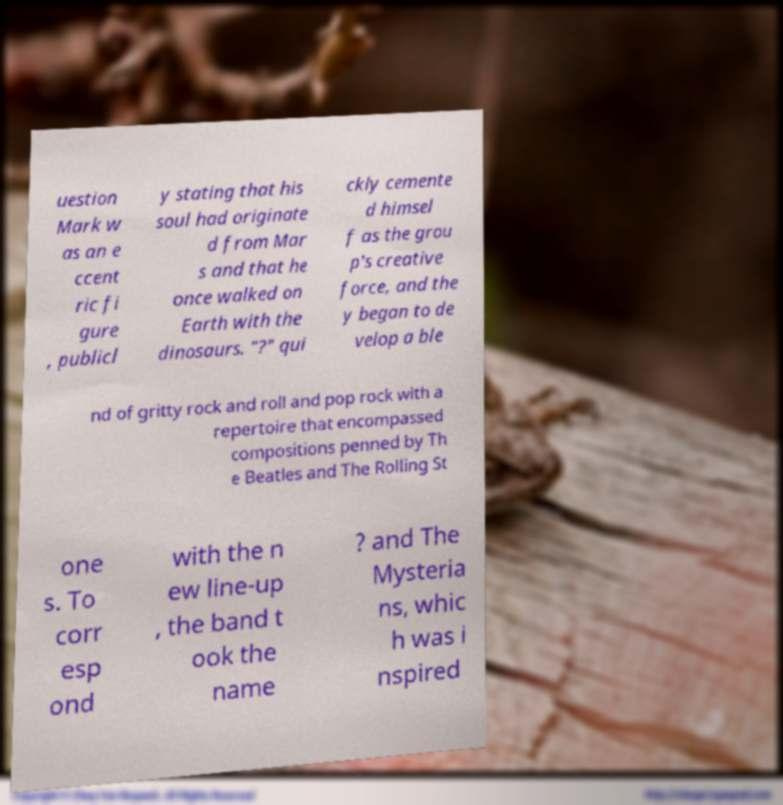Can you read and provide the text displayed in the image?This photo seems to have some interesting text. Can you extract and type it out for me? uestion Mark w as an e ccent ric fi gure , publicl y stating that his soul had originate d from Mar s and that he once walked on Earth with the dinosaurs. "?" qui ckly cemente d himsel f as the grou p's creative force, and the y began to de velop a ble nd of gritty rock and roll and pop rock with a repertoire that encompassed compositions penned by Th e Beatles and The Rolling St one s. To corr esp ond with the n ew line-up , the band t ook the name ? and The Mysteria ns, whic h was i nspired 